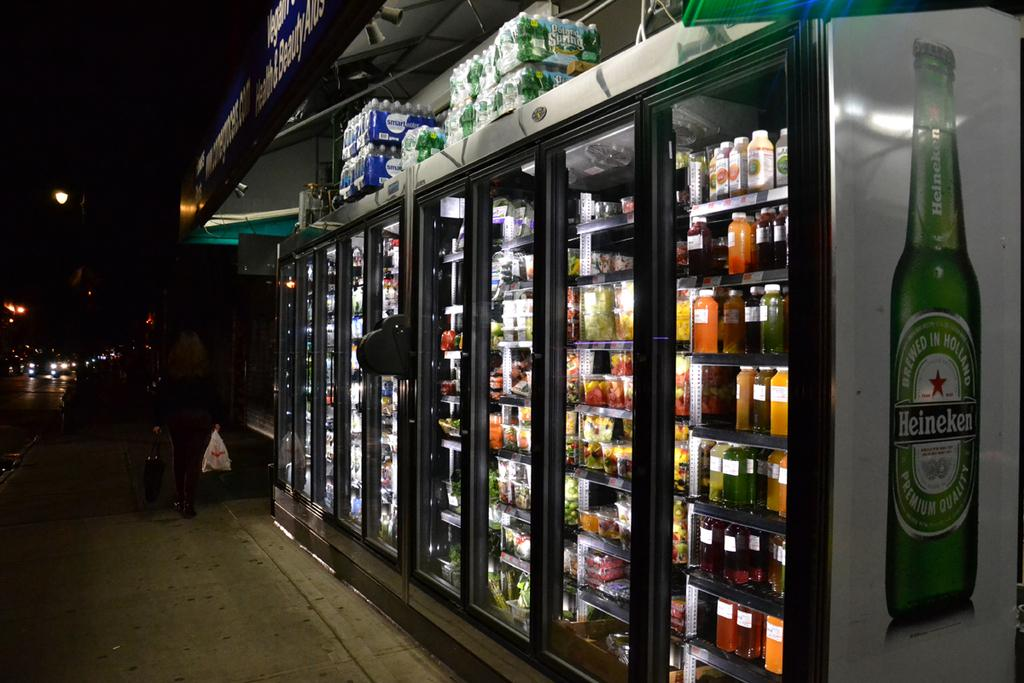<image>
Share a concise interpretation of the image provided. A refrigerator with a picture of a giant Heineken bottle on the side. 